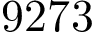<formula> <loc_0><loc_0><loc_500><loc_500>9 2 7 3</formula> 